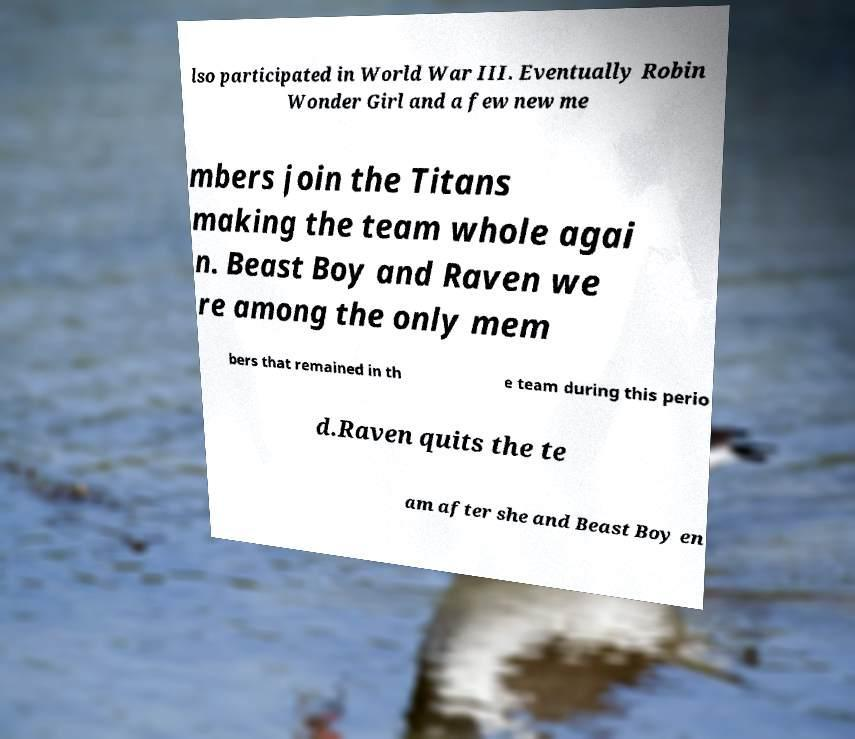Could you extract and type out the text from this image? lso participated in World War III. Eventually Robin Wonder Girl and a few new me mbers join the Titans making the team whole agai n. Beast Boy and Raven we re among the only mem bers that remained in th e team during this perio d.Raven quits the te am after she and Beast Boy en 